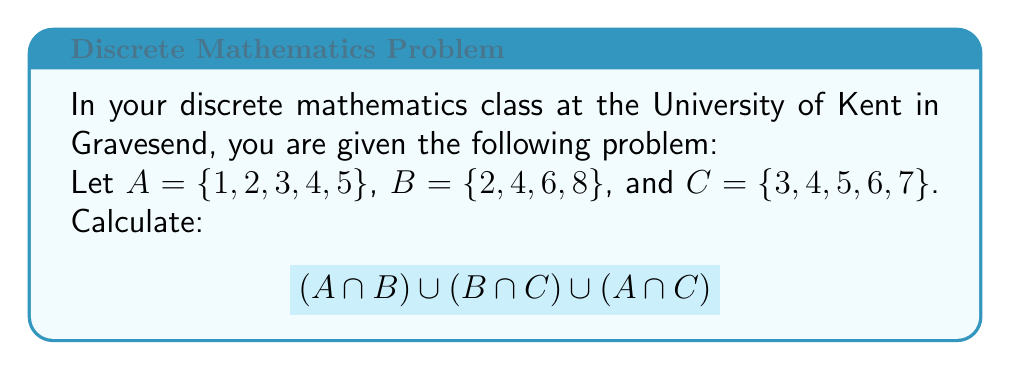Can you solve this math problem? Let's approach this problem step by step using set theory concepts:

1) First, we need to find the intersections:

   $A \cap B = \{2, 4\}$
   $B \cap C = \{4, 6\}$
   $A \cap C = \{3, 4, 5\}$

2) Now, we need to find the union of these intersections:

   $(A \cap B) \cup (B \cap C) \cup (A \cap C)$

   We can do this by listing all unique elements from these sets:

   $\{2, 4\} \cup \{4, 6\} \cup \{3, 4, 5\}$

3) Combining all unique elements:

   $\{2, 3, 4, 5, 6\}$

   Note that 4 appears in all three sets, but we only include it once in the final result.

This process demonstrates the use of set operations (intersection and union) to solve a discrete mathematics problem.
Answer: $\{2, 3, 4, 5, 6\}$ 